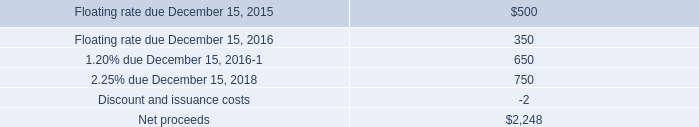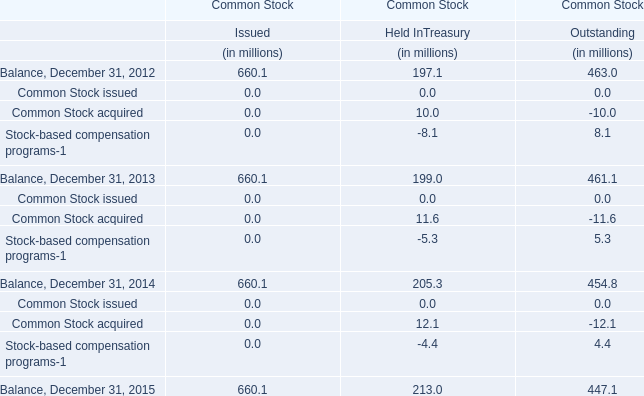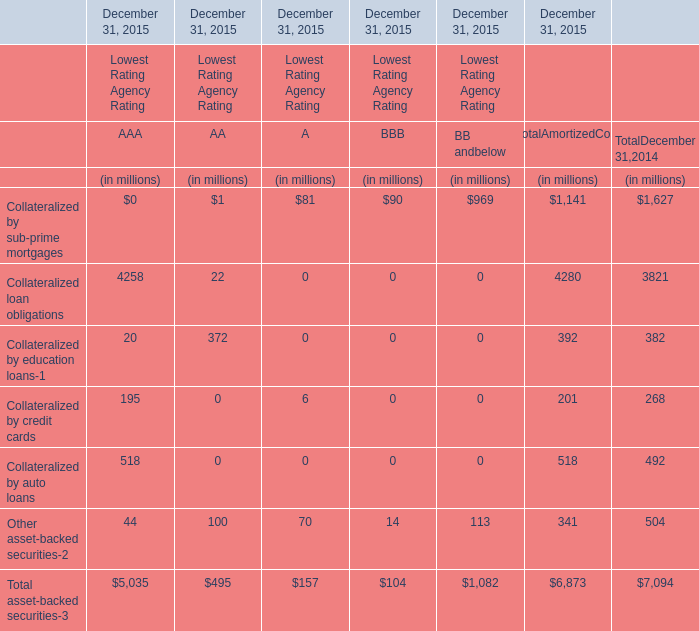What do all Collateralized by sub-prime mortgages of lowest rating agency rating sum up in 2015 for total amortized cost , excluding AAA and BBB? (in million) 
Computations: ((1 + 81) + 969)
Answer: 1051.0. 